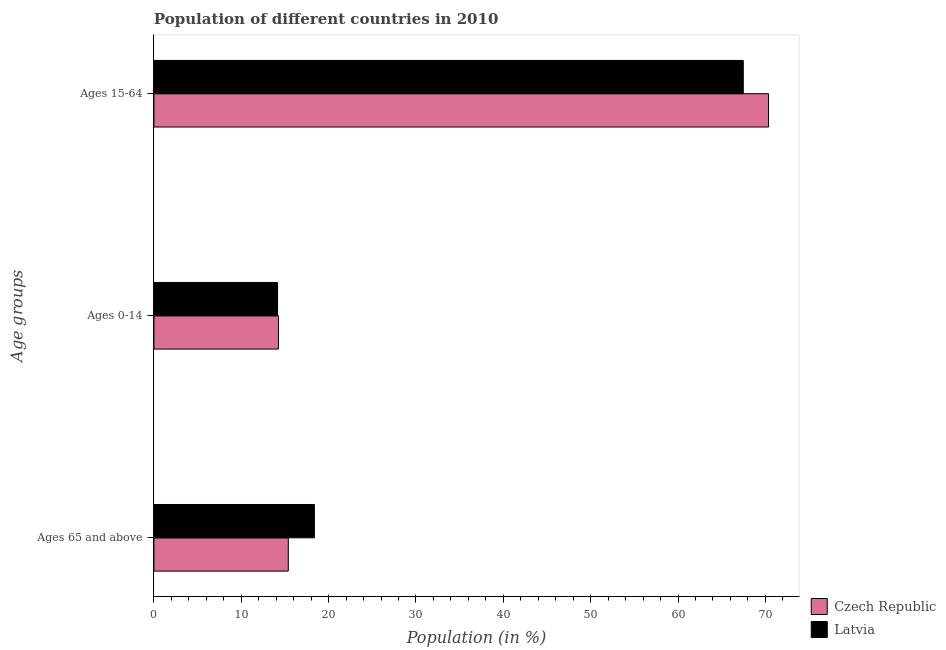How many different coloured bars are there?
Your answer should be compact. 2. How many groups of bars are there?
Provide a short and direct response. 3. How many bars are there on the 3rd tick from the top?
Your response must be concise. 2. How many bars are there on the 3rd tick from the bottom?
Your answer should be compact. 2. What is the label of the 1st group of bars from the top?
Ensure brevity in your answer.  Ages 15-64. What is the percentage of population within the age-group 15-64 in Latvia?
Give a very brief answer. 67.47. Across all countries, what is the maximum percentage of population within the age-group of 65 and above?
Keep it short and to the point. 18.37. Across all countries, what is the minimum percentage of population within the age-group of 65 and above?
Make the answer very short. 15.38. In which country was the percentage of population within the age-group 15-64 maximum?
Give a very brief answer. Czech Republic. In which country was the percentage of population within the age-group 15-64 minimum?
Your response must be concise. Latvia. What is the total percentage of population within the age-group of 65 and above in the graph?
Make the answer very short. 33.76. What is the difference between the percentage of population within the age-group of 65 and above in Czech Republic and that in Latvia?
Offer a terse response. -2.99. What is the difference between the percentage of population within the age-group of 65 and above in Latvia and the percentage of population within the age-group 0-14 in Czech Republic?
Provide a short and direct response. 4.12. What is the average percentage of population within the age-group 0-14 per country?
Offer a terse response. 14.2. What is the difference between the percentage of population within the age-group 15-64 and percentage of population within the age-group of 65 and above in Czech Republic?
Give a very brief answer. 54.98. What is the ratio of the percentage of population within the age-group of 65 and above in Czech Republic to that in Latvia?
Offer a very short reply. 0.84. Is the difference between the percentage of population within the age-group 0-14 in Latvia and Czech Republic greater than the difference between the percentage of population within the age-group 15-64 in Latvia and Czech Republic?
Your answer should be compact. Yes. What is the difference between the highest and the second highest percentage of population within the age-group 0-14?
Keep it short and to the point. 0.1. What is the difference between the highest and the lowest percentage of population within the age-group 15-64?
Your response must be concise. 2.89. What does the 2nd bar from the top in Ages 65 and above represents?
Give a very brief answer. Czech Republic. What does the 2nd bar from the bottom in Ages 0-14 represents?
Your answer should be compact. Latvia. How many bars are there?
Provide a succinct answer. 6. What is the difference between two consecutive major ticks on the X-axis?
Offer a very short reply. 10. Does the graph contain any zero values?
Your answer should be very brief. No. How are the legend labels stacked?
Offer a terse response. Vertical. What is the title of the graph?
Provide a succinct answer. Population of different countries in 2010. Does "Latvia" appear as one of the legend labels in the graph?
Your answer should be very brief. Yes. What is the label or title of the Y-axis?
Your response must be concise. Age groups. What is the Population (in %) in Czech Republic in Ages 65 and above?
Give a very brief answer. 15.38. What is the Population (in %) in Latvia in Ages 65 and above?
Offer a very short reply. 18.37. What is the Population (in %) of Czech Republic in Ages 0-14?
Make the answer very short. 14.25. What is the Population (in %) in Latvia in Ages 0-14?
Offer a very short reply. 14.15. What is the Population (in %) in Czech Republic in Ages 15-64?
Your answer should be compact. 70.36. What is the Population (in %) in Latvia in Ages 15-64?
Offer a very short reply. 67.47. Across all Age groups, what is the maximum Population (in %) in Czech Republic?
Give a very brief answer. 70.36. Across all Age groups, what is the maximum Population (in %) in Latvia?
Your response must be concise. 67.47. Across all Age groups, what is the minimum Population (in %) of Czech Republic?
Your answer should be very brief. 14.25. Across all Age groups, what is the minimum Population (in %) of Latvia?
Make the answer very short. 14.15. What is the total Population (in %) of Czech Republic in the graph?
Your answer should be compact. 100. What is the difference between the Population (in %) of Czech Republic in Ages 65 and above and that in Ages 0-14?
Offer a very short reply. 1.13. What is the difference between the Population (in %) in Latvia in Ages 65 and above and that in Ages 0-14?
Offer a very short reply. 4.22. What is the difference between the Population (in %) in Czech Republic in Ages 65 and above and that in Ages 15-64?
Your answer should be very brief. -54.98. What is the difference between the Population (in %) in Latvia in Ages 65 and above and that in Ages 15-64?
Your answer should be compact. -49.1. What is the difference between the Population (in %) of Czech Republic in Ages 0-14 and that in Ages 15-64?
Keep it short and to the point. -56.11. What is the difference between the Population (in %) in Latvia in Ages 0-14 and that in Ages 15-64?
Your answer should be compact. -53.32. What is the difference between the Population (in %) in Czech Republic in Ages 65 and above and the Population (in %) in Latvia in Ages 0-14?
Provide a short and direct response. 1.23. What is the difference between the Population (in %) of Czech Republic in Ages 65 and above and the Population (in %) of Latvia in Ages 15-64?
Make the answer very short. -52.09. What is the difference between the Population (in %) of Czech Republic in Ages 0-14 and the Population (in %) of Latvia in Ages 15-64?
Give a very brief answer. -53.22. What is the average Population (in %) of Czech Republic per Age groups?
Make the answer very short. 33.33. What is the average Population (in %) in Latvia per Age groups?
Your answer should be very brief. 33.33. What is the difference between the Population (in %) in Czech Republic and Population (in %) in Latvia in Ages 65 and above?
Ensure brevity in your answer.  -2.99. What is the difference between the Population (in %) of Czech Republic and Population (in %) of Latvia in Ages 0-14?
Ensure brevity in your answer.  0.1. What is the difference between the Population (in %) in Czech Republic and Population (in %) in Latvia in Ages 15-64?
Your answer should be compact. 2.89. What is the ratio of the Population (in %) of Czech Republic in Ages 65 and above to that in Ages 0-14?
Your answer should be compact. 1.08. What is the ratio of the Population (in %) in Latvia in Ages 65 and above to that in Ages 0-14?
Your answer should be compact. 1.3. What is the ratio of the Population (in %) in Czech Republic in Ages 65 and above to that in Ages 15-64?
Your answer should be compact. 0.22. What is the ratio of the Population (in %) in Latvia in Ages 65 and above to that in Ages 15-64?
Offer a very short reply. 0.27. What is the ratio of the Population (in %) in Czech Republic in Ages 0-14 to that in Ages 15-64?
Keep it short and to the point. 0.2. What is the ratio of the Population (in %) in Latvia in Ages 0-14 to that in Ages 15-64?
Give a very brief answer. 0.21. What is the difference between the highest and the second highest Population (in %) of Czech Republic?
Your response must be concise. 54.98. What is the difference between the highest and the second highest Population (in %) of Latvia?
Provide a short and direct response. 49.1. What is the difference between the highest and the lowest Population (in %) in Czech Republic?
Give a very brief answer. 56.11. What is the difference between the highest and the lowest Population (in %) of Latvia?
Offer a terse response. 53.32. 